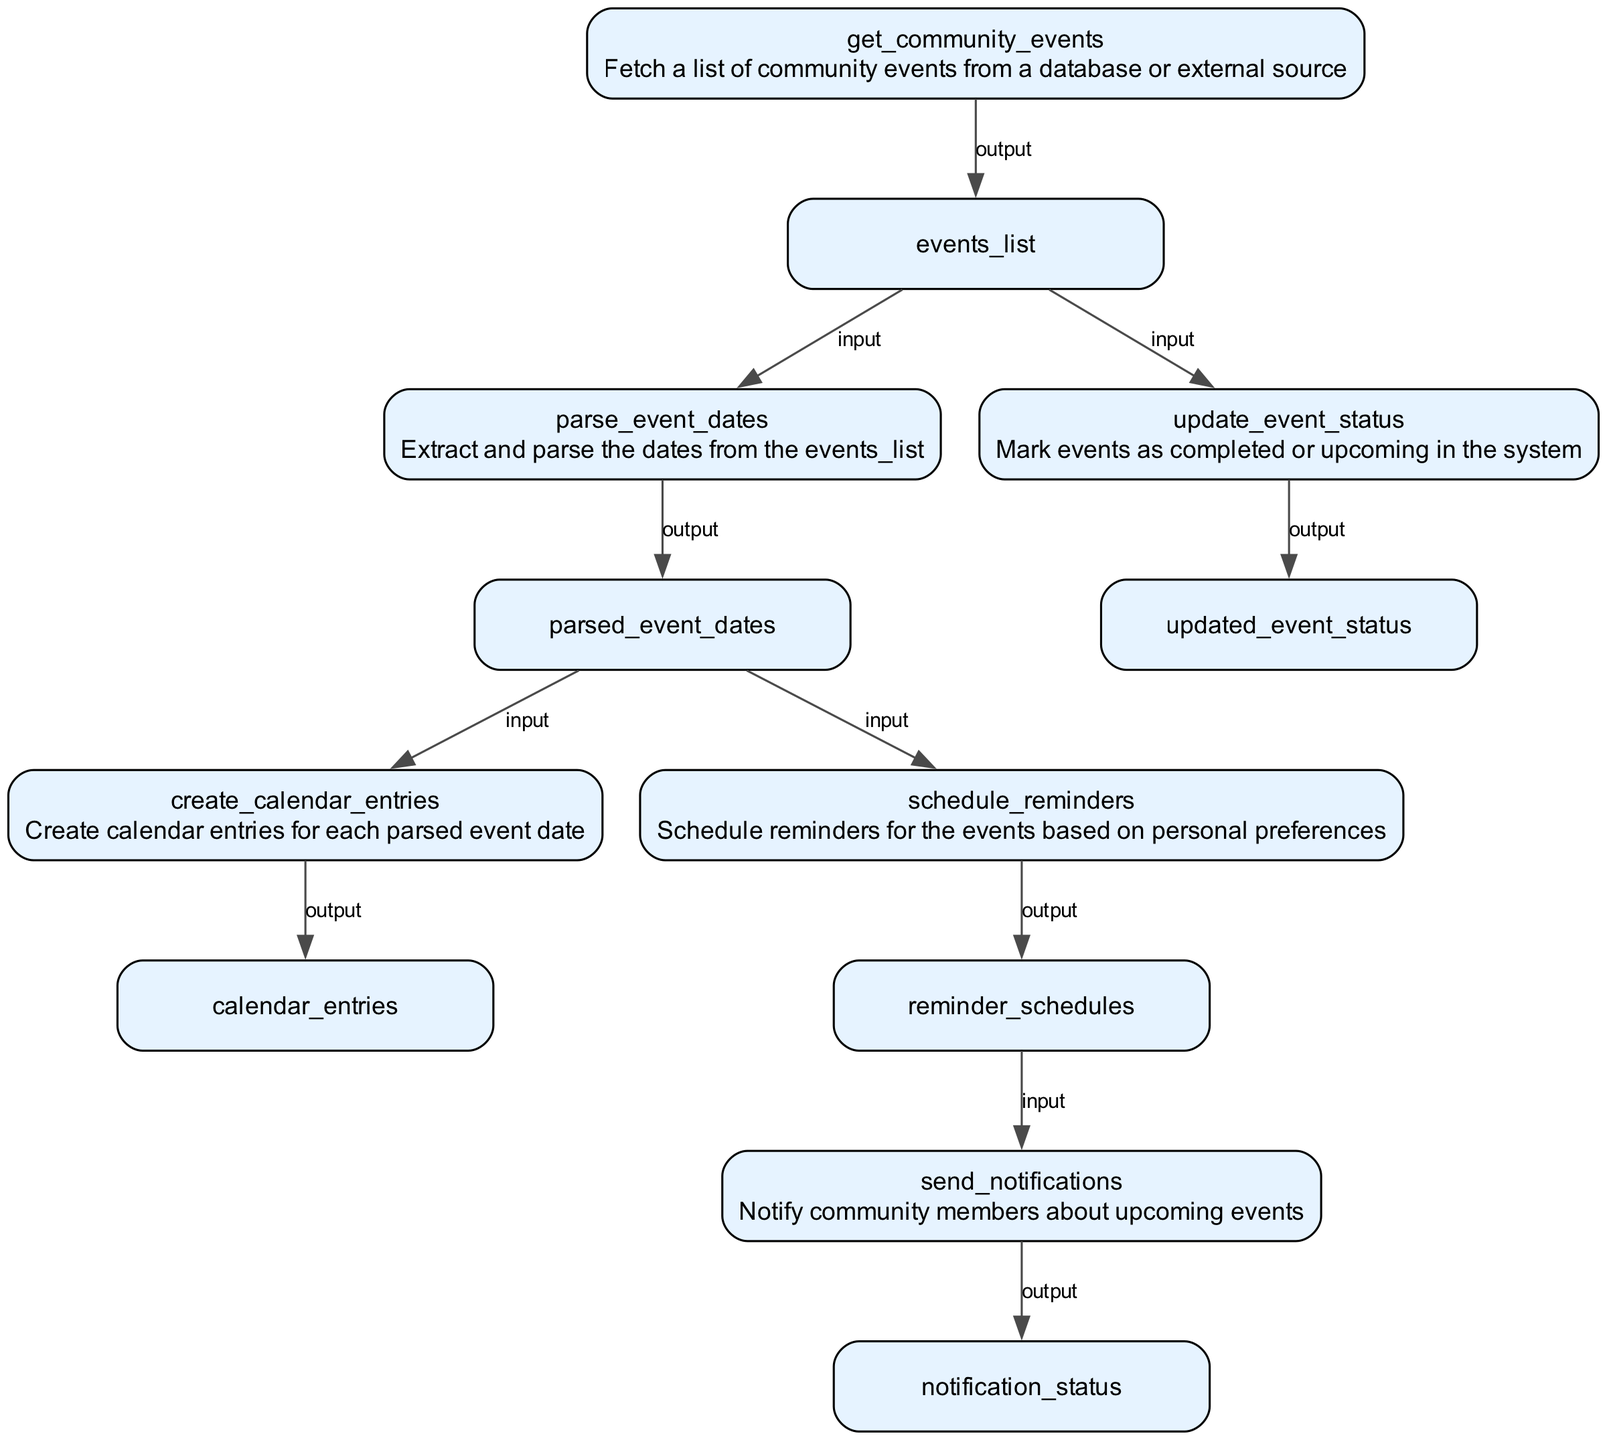What is the first action in the flowchart? The first action is represented by the node "get_community_events," which indicates that it fetches a list of community events from a database or external source.
Answer: Fetch a list of community events from a database or external source How many nodes are in the flowchart? The flowchart contains six distinct nodes, each representing a separate action in the system.
Answer: Six What is the output of the "schedule_reminders" action? The output from the "schedule_reminders" action is "reminder_schedules," which indicates the schedules for reminders created based on the parsed event dates.
Answer: Reminder schedules What is the relationship between "parse_event_dates" and "create_calendar_entries"? "parse_event_dates" sends its output "parsed_event_dates" as an input to "create_calendar_entries," indicating that the parsed event dates are necessary to create calendar entries.
Answer: Parsed event dates Which action sends notifications to community members? The action responsible for notifying community members is "send_notifications." This action takes in "reminder_schedules" as input to carry out the notifications.
Answer: Send notifications What type of data does "create_calendar_entries" process? The "create_calendar_entries" action processes the "parsed_event_dates," which indicates that it uses the dates extracted from community events to create calendar entries.
Answer: Parsed event dates What are the inputs required for the "send_notifications" action? The "send_notifications" action requires "reminder_schedules" as its input, meaning it utilizes the scheduled reminders to notify community members about the events.
Answer: Reminder schedules Which node marks events as completed or upcoming? The node responsible for marking events is "update_event_status," which determines the status of events based on the input from the "events_list."
Answer: Update event status 